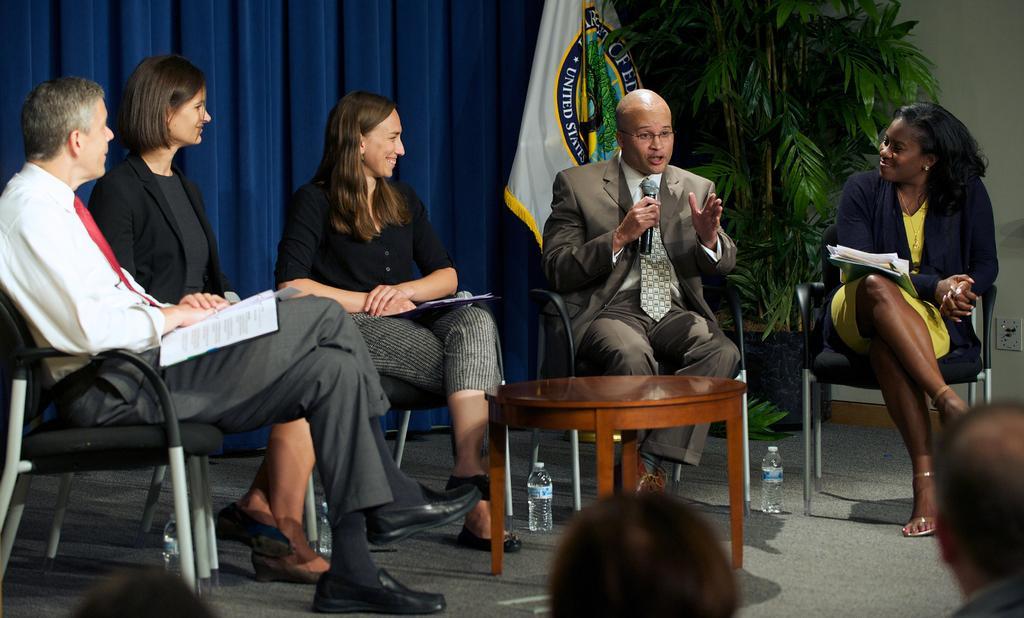Can you describe this image briefly? There are persons in different color dresses smiling and sitting. One of them is holding a mic and speaking. In front them, there is a table on the stage on which, there are bottles, a pot plant and a flag and there are persons. In the background, there is a violet color curtain and there is a white color wall. 